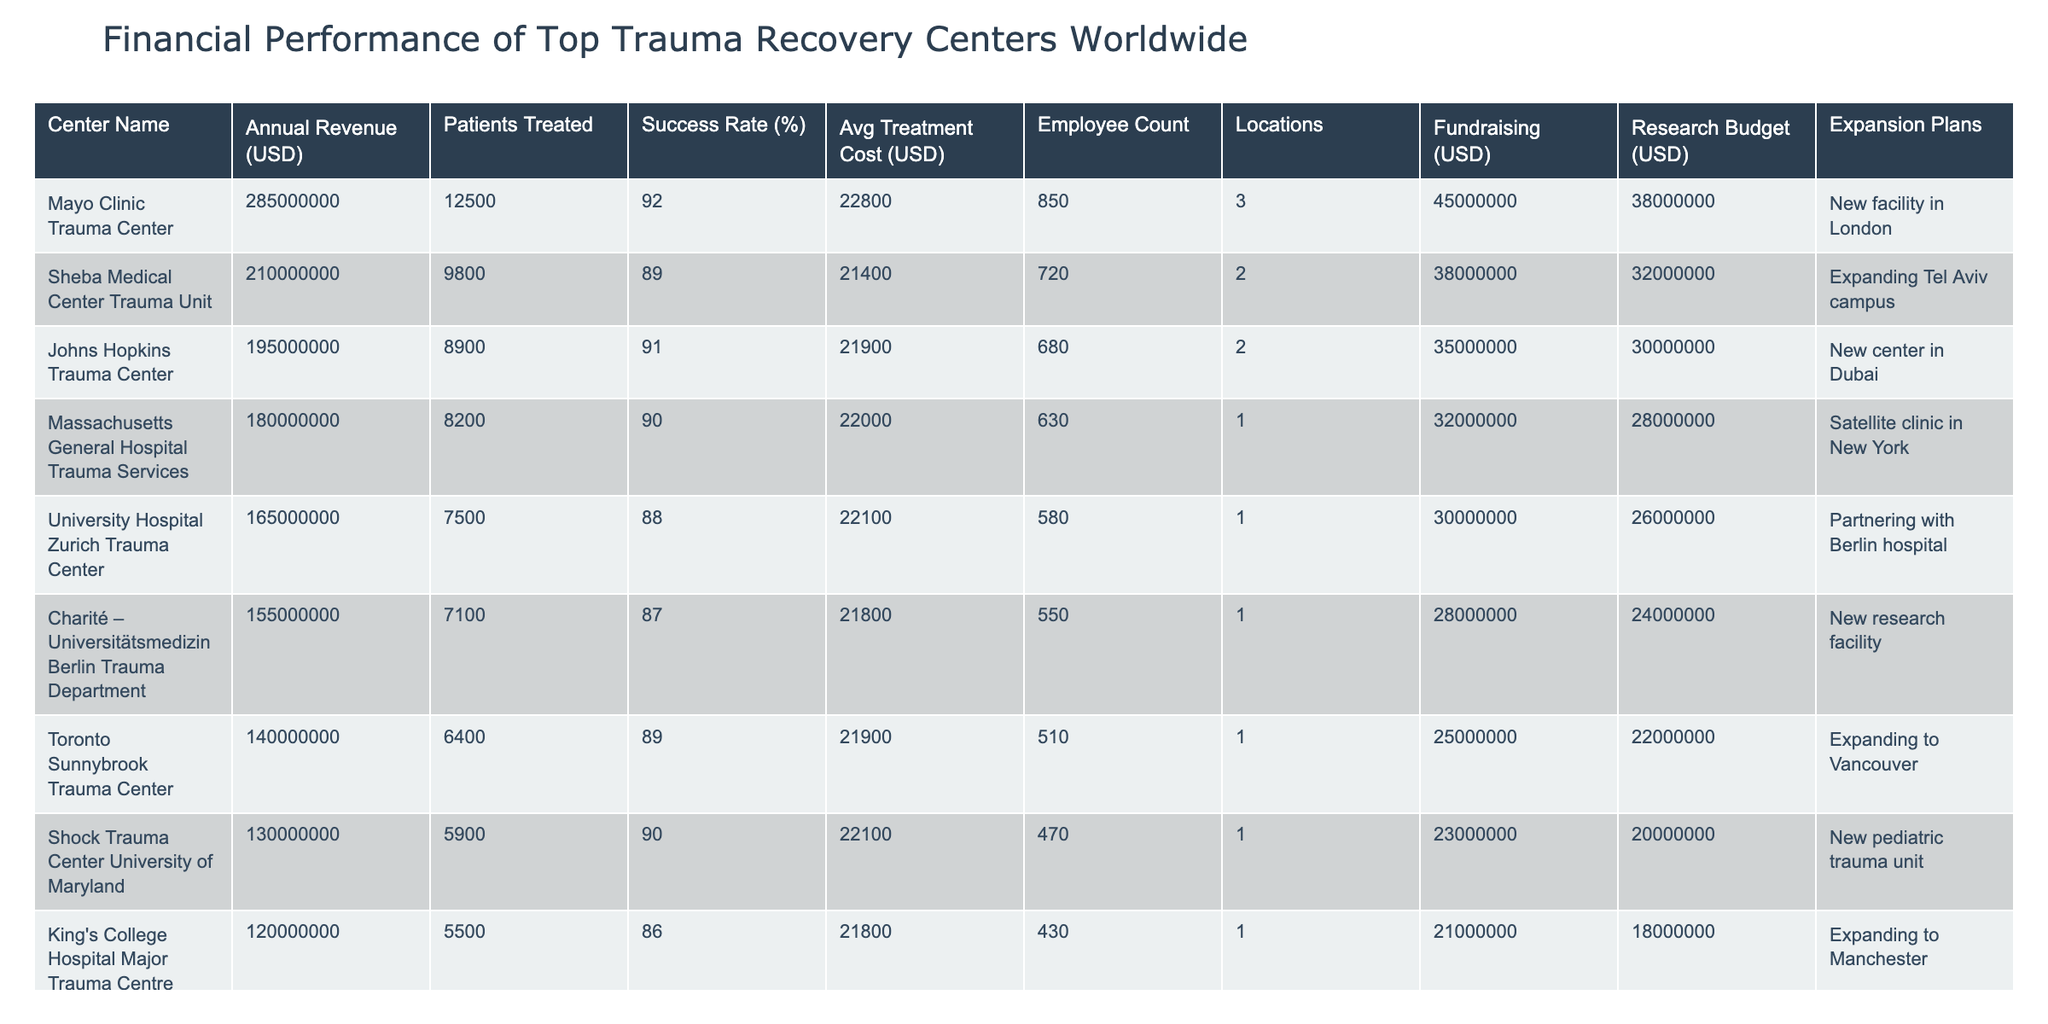What is the annual revenue of the Mayo Clinic Trauma Center? The annual revenue for the Mayo Clinic Trauma Center is explicitly stated in the table as 285,000,000 USD.
Answer: 285000000 How many patients were treated at the Sheba Medical Center Trauma Unit? The table shows that the Sheba Medical Center Trauma Unit treated 9,800 patients.
Answer: 9800 What is the success rate of the Johns Hopkins Trauma Center? The success rate listed for the Johns Hopkins Trauma Center in the table is 91%.
Answer: 91 Which trauma center has the highest fundraising amount? By examining the fundraising column, the Mayo Clinic Trauma Center has the highest amount at 45,000,000 USD.
Answer: Mayo Clinic Trauma Center What is the average treatment cost at the Massachusetts General Hospital Trauma Services? The average treatment cost for the Massachusetts General Hospital Trauma Services is 22,000 USD, as provided in the table.
Answer: 22000 Calculate the total number of patients treated across all centers listed in the table. First, sum the patients treated: 12,500 + 9,800 + 8,900 + 8,200 + 7,500 + 7,100 + 6,400 + 5,900 + 5,500 + 5,000 = 77,000 patients.
Answer: 77000 Is the success rate of the Charité – Universitätsmedizin Berlin Trauma Department higher than 90%? According to the table, the success rate of Charité is 87%, which is not higher than 90%.
Answer: No Which center has the lowest average treatment cost and what is that cost? The Groote Schuur Hospital Trauma Center has the lowest average treatment cost of 22,000 USD, evidenced by comparing the average treatment costs across the table.
Answer: 22000 If we consider expansion plans, how many centers are planning to expand their facilities? The table indicates that 7 centers are planning to expand their facilities, as listed in their respective rows under the Expansion Plans column.
Answer: 7 Which trauma center has the highest number of employees, and how many are there? The table shows the Mayo Clinic Trauma Center has the highest employee count at 850, as seen in the Employee Count column.
Answer: 850 What is the difference in annual revenue between the John Hopkins Trauma Center and the Groote Schuur Hospital Trauma Center? The annual revenue for Johns Hopkins is 195,000,000 USD and for Groote Schuur it's 110,000,000 USD. The difference is 195,000,000 - 110,000,000 = 85,000,000 USD.
Answer: 85000000 